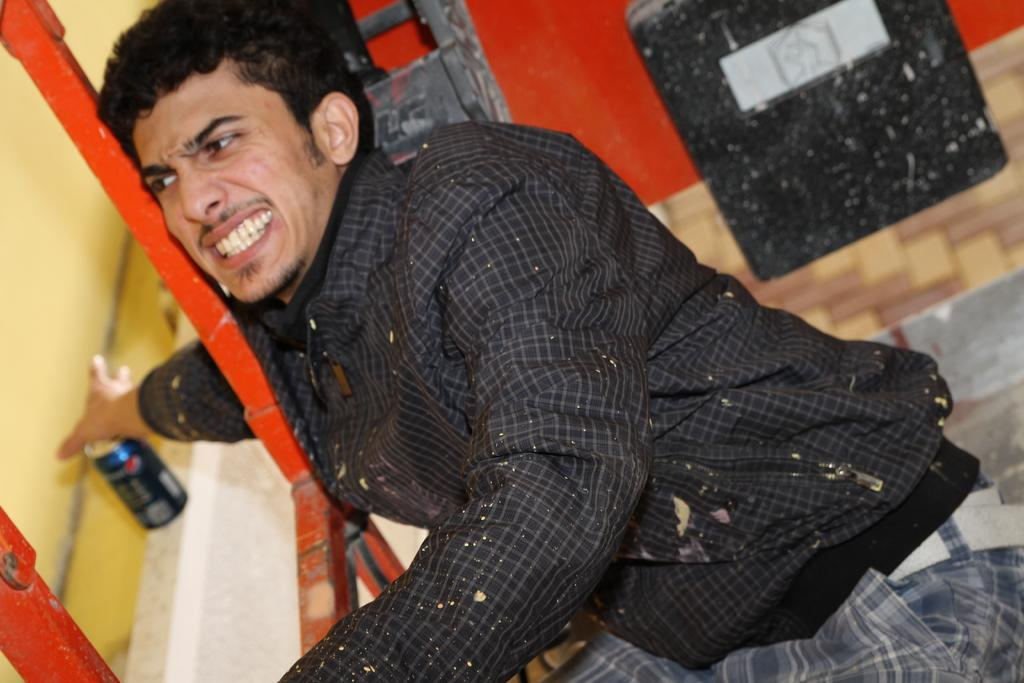What is the main subject of the image? The main subject of the image is a man. What is the man doing in the image? The man is trying to hold a can on a stand. Can you describe the stand in the image? The stand in the image is red in color. What can be seen in the background of the image? There is a wall in the background of the image. Are there any other items visible in the image? Yes, there are some other items in the image. What type of pest can be seen crawling on the wall in the image? There is no pest visible on the wall in the image. Where can you find the market in the image? There is no market present in the image. 